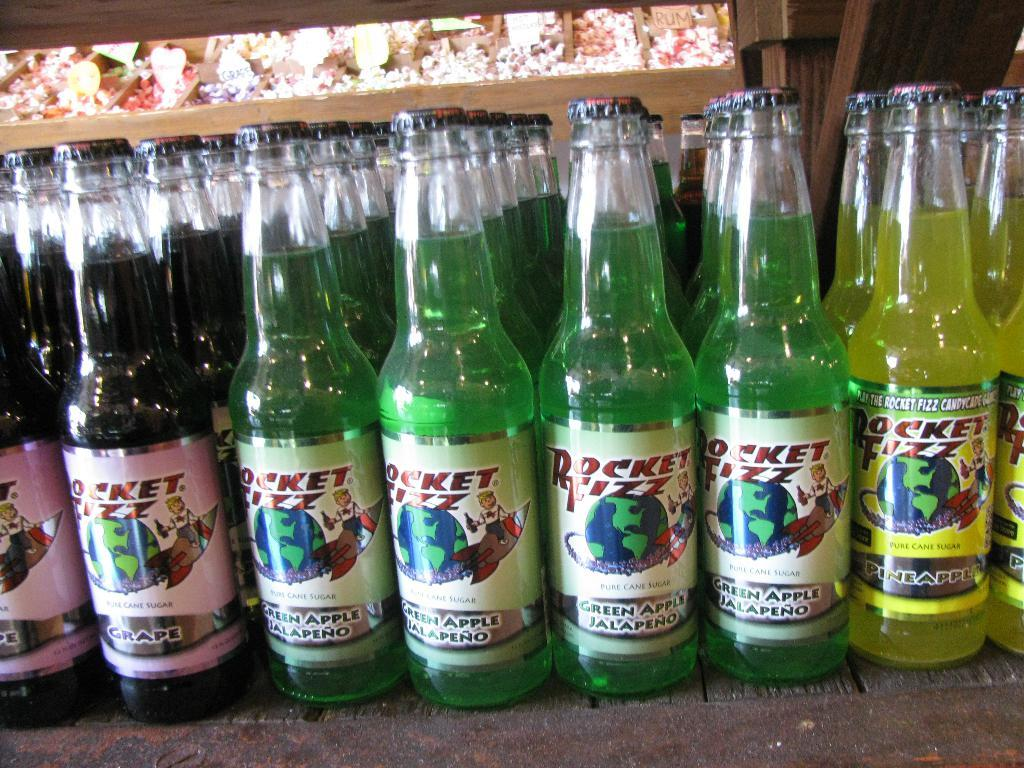<image>
Give a short and clear explanation of the subsequent image. A row of Rocket Fizz bottles including grape flavors and green apple jalapeno. 